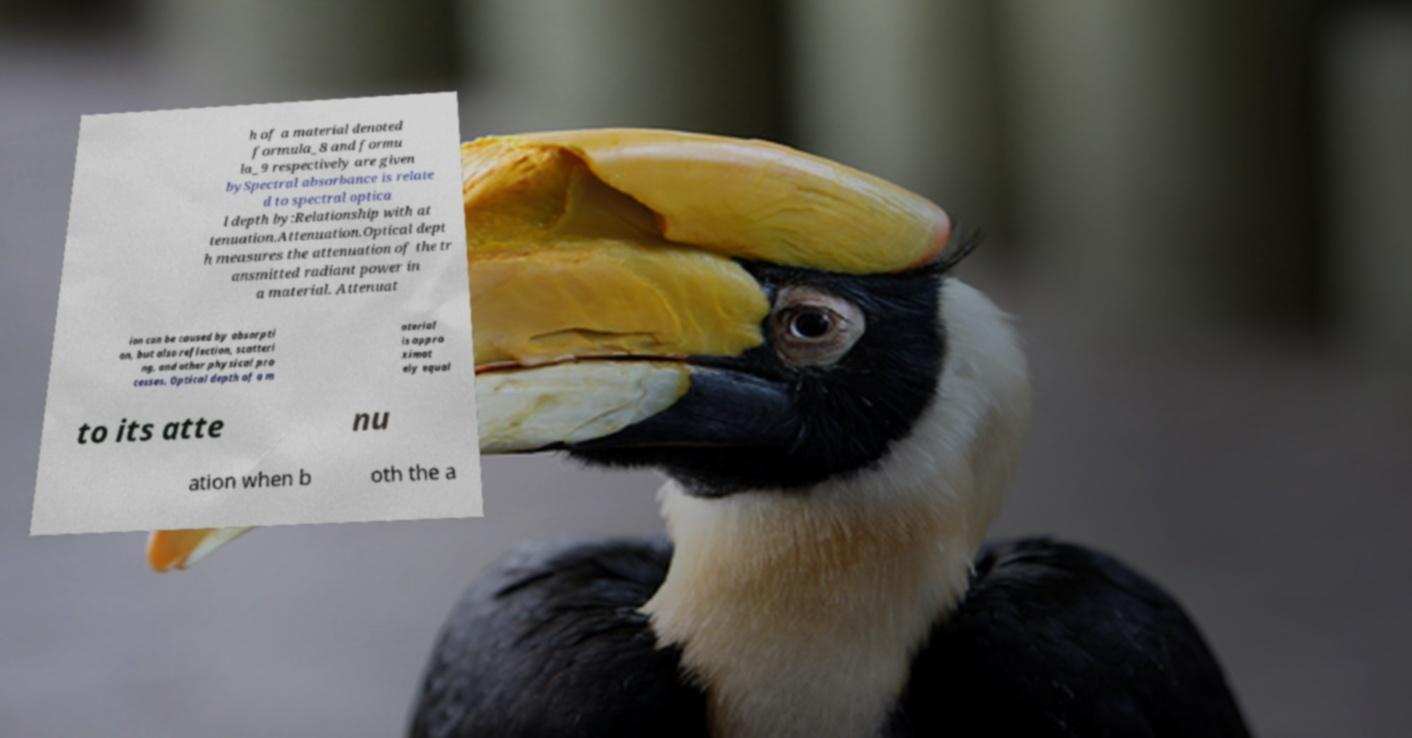What messages or text are displayed in this image? I need them in a readable, typed format. h of a material denoted formula_8 and formu la_9 respectively are given bySpectral absorbance is relate d to spectral optica l depth by:Relationship with at tenuation.Attenuation.Optical dept h measures the attenuation of the tr ansmitted radiant power in a material. Attenuat ion can be caused by absorpti on, but also reflection, scatteri ng, and other physical pro cesses. Optical depth of a m aterial is appro ximat ely equal to its atte nu ation when b oth the a 